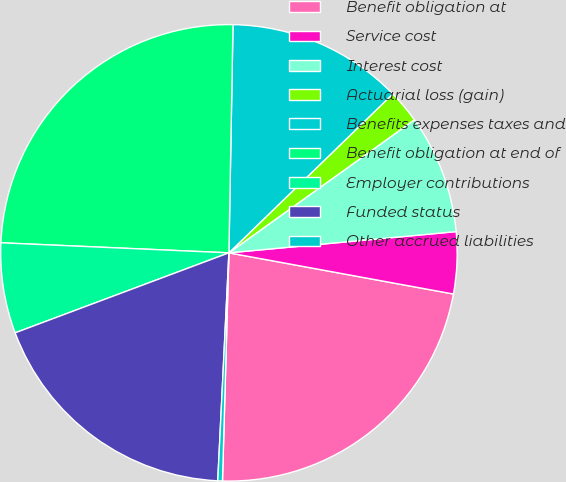Convert chart. <chart><loc_0><loc_0><loc_500><loc_500><pie_chart><fcel>Benefit obligation at<fcel>Service cost<fcel>Interest cost<fcel>Actuarial loss (gain)<fcel>Benefits expenses taxes and<fcel>Benefit obligation at end of<fcel>Employer contributions<fcel>Funded status<fcel>Other accrued liabilities<nl><fcel>22.56%<fcel>4.37%<fcel>8.42%<fcel>2.35%<fcel>12.46%<fcel>24.58%<fcel>6.4%<fcel>18.52%<fcel>0.33%<nl></chart> 